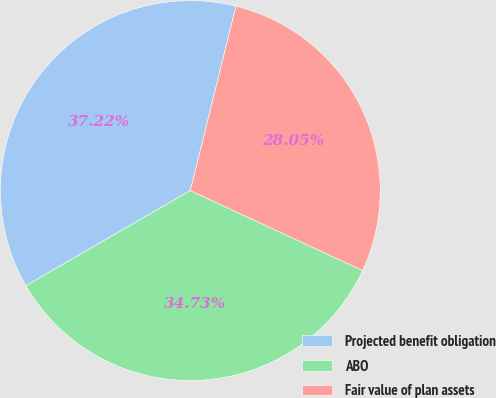Convert chart. <chart><loc_0><loc_0><loc_500><loc_500><pie_chart><fcel>Projected benefit obligation<fcel>ABO<fcel>Fair value of plan assets<nl><fcel>37.22%<fcel>34.73%<fcel>28.05%<nl></chart> 